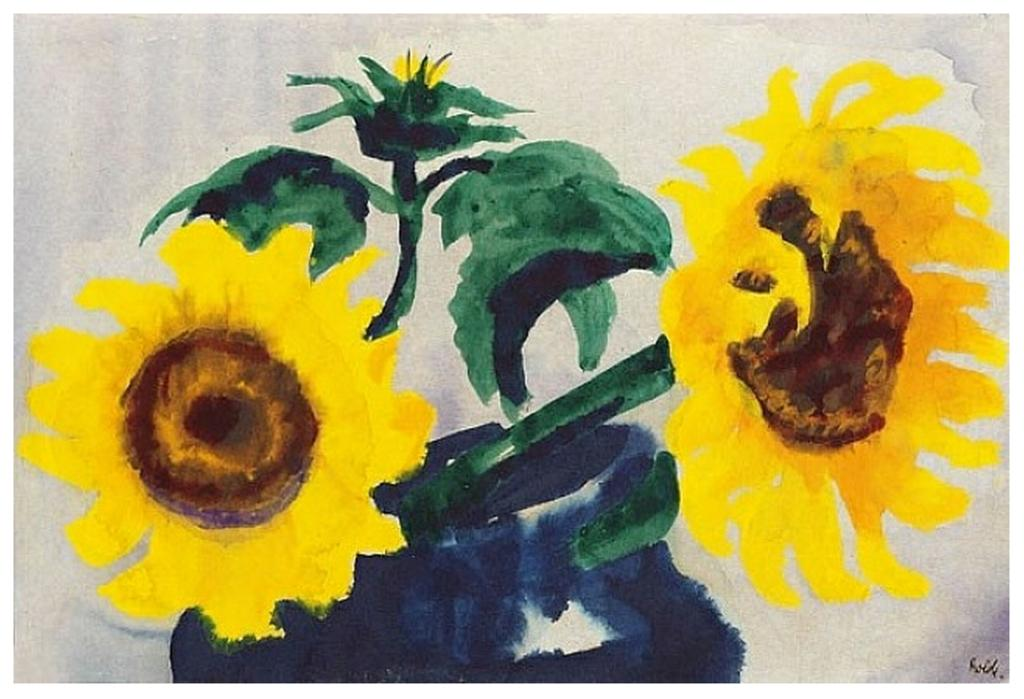What is the main subject of the painting in the image? The painting depicts sunflowers. Are there any other elements in the painting besides sunflowers? Yes, leaves are present in the painting. What type of hill can be seen in the background of the painting? There is no hill present in the painting; it features sunflowers and leaves. What color is the cast on the sunflower's arm in the painting? There is no cast or arm present on the sunflowers in the painting, as they are depicted as plants. 